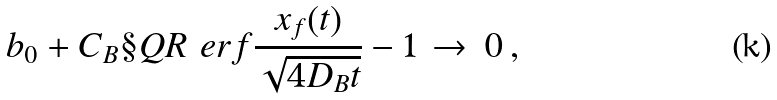Convert formula to latex. <formula><loc_0><loc_0><loc_500><loc_500>b _ { 0 } + C _ { B } \S Q R { \ e r f { \frac { x _ { f } ( t ) } { \sqrt { 4 D _ { B } t } } } - 1 } \, \to \, 0 \, ,</formula> 